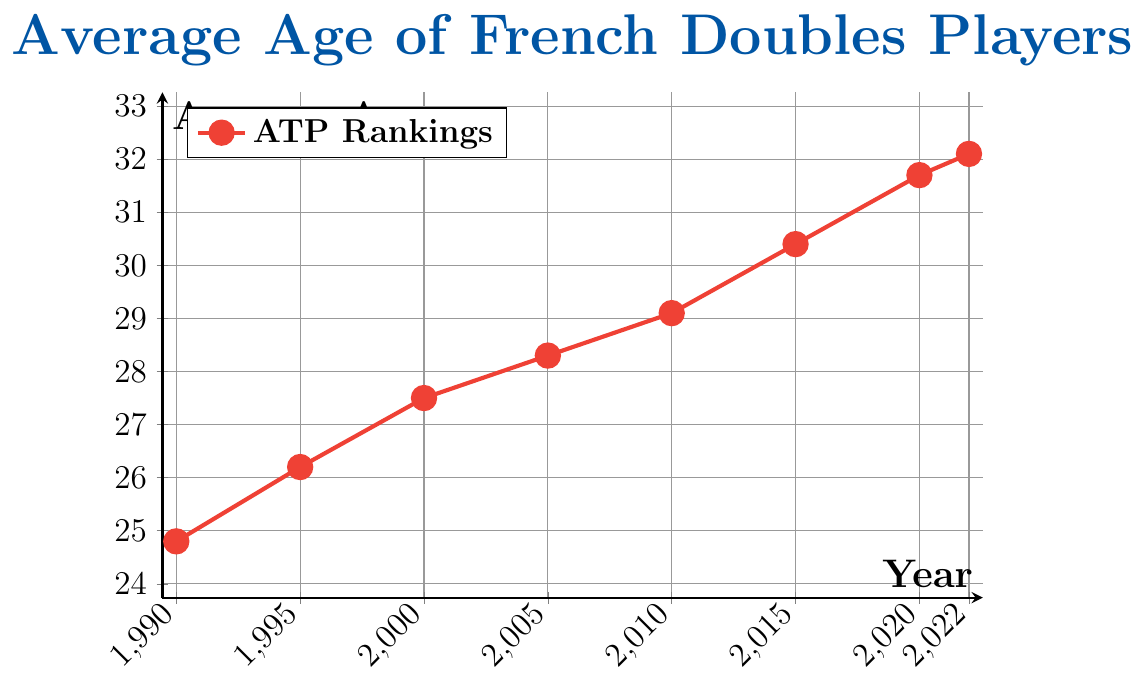What is the overall trend in the average age of French doubles players from 1990 to 2022? The plot shows a year-by-year increase in the average age. Starting from 24.8 in 1990, it consistently rises, reaching 32.1 by 2022. Hence, the overall trend is an upward one.
Answer: Upward trend How much older were French doubles players on average in 2022 compared to 1990? In 1990, the average age was 24.8, and in 2022, it was 32.1. The difference in age is 32.1 - 24.8 = 7.3 years.
Answer: 7.3 years Which year saw the highest average age of French doubles players? By inspecting the plot, the highest point on the y-axis corresponds to the year 2022 with an average age of 32.1.
Answer: 2022 In which year did the average age of French doubles players first surpass 30? Observing the plot, the year when the average age first surpassed 30 is 2015, where the average age is 30.4.
Answer: 2015 Which period saw the greatest increase in the average age of French doubles players? We calculate the difference over each period: 1990-1995 (26.2-24.8=1.4), 1995-2000 (27.5-26.2=1.3), 2000-2005 (28.3-27.5=0.8), 2005-2010 (29.1-28.3=0.8), 2010-2015 (30.4-29.1=1.3), 2015-2020 (31.7-30.4=1.3), 2020-2022 (32.1-31.7=0.4). The greatest increase (1.4) is between 1990 and 1995.
Answer: 1990-1995 By how many years did the average age increase between 2010 and 2022? The average age in 2010 was 29.1, and in 2022 it was 32.1, resulting in an increase of 32.1 - 29.1 = 3.0 years.
Answer: 3.0 years How does the average age change between each recorded interval? We look at each interval: 1990-1995 (1.4), 1995-2000 (1.3), 2000-2005 (0.8), 2005-2010 (0.8), 2010-2015 (1.3), 2015-2020 (1.3), 2020-2022 (0.4). This shows incremental increases with varying magnitudes.
Answer: Varies (1.4, 1.3, 0.8, 0.8, 1.3, 1.3, 0.4) What visual feature helps identify the general trend from 1990 to 2022? The plot line, which is steadily increasing from left to right, visually indicates the general upward trend in the average age of French doubles players.
Answer: Steadily increasing line Is there any period where the average age remained constant? The plot does not show any horizontal sections, indicating that the average age never remained constant between the recorded years.
Answer: No 